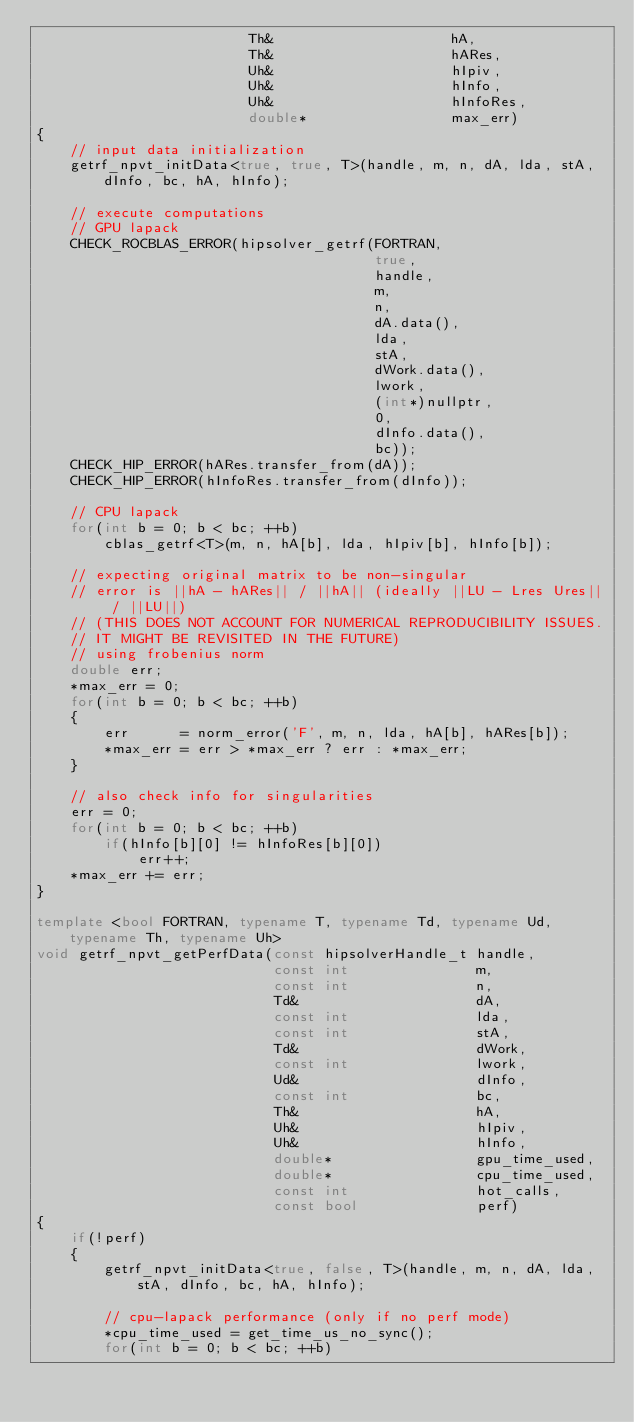<code> <loc_0><loc_0><loc_500><loc_500><_C++_>                         Th&                     hA,
                         Th&                     hARes,
                         Uh&                     hIpiv,
                         Uh&                     hInfo,
                         Uh&                     hInfoRes,
                         double*                 max_err)
{
    // input data initialization
    getrf_npvt_initData<true, true, T>(handle, m, n, dA, lda, stA, dInfo, bc, hA, hInfo);

    // execute computations
    // GPU lapack
    CHECK_ROCBLAS_ERROR(hipsolver_getrf(FORTRAN,
                                        true,
                                        handle,
                                        m,
                                        n,
                                        dA.data(),
                                        lda,
                                        stA,
                                        dWork.data(),
                                        lwork,
                                        (int*)nullptr,
                                        0,
                                        dInfo.data(),
                                        bc));
    CHECK_HIP_ERROR(hARes.transfer_from(dA));
    CHECK_HIP_ERROR(hInfoRes.transfer_from(dInfo));

    // CPU lapack
    for(int b = 0; b < bc; ++b)
        cblas_getrf<T>(m, n, hA[b], lda, hIpiv[b], hInfo[b]);

    // expecting original matrix to be non-singular
    // error is ||hA - hARes|| / ||hA|| (ideally ||LU - Lres Ures|| / ||LU||)
    // (THIS DOES NOT ACCOUNT FOR NUMERICAL REPRODUCIBILITY ISSUES.
    // IT MIGHT BE REVISITED IN THE FUTURE)
    // using frobenius norm
    double err;
    *max_err = 0;
    for(int b = 0; b < bc; ++b)
    {
        err      = norm_error('F', m, n, lda, hA[b], hARes[b]);
        *max_err = err > *max_err ? err : *max_err;
    }

    // also check info for singularities
    err = 0;
    for(int b = 0; b < bc; ++b)
        if(hInfo[b][0] != hInfoRes[b][0])
            err++;
    *max_err += err;
}

template <bool FORTRAN, typename T, typename Td, typename Ud, typename Th, typename Uh>
void getrf_npvt_getPerfData(const hipsolverHandle_t handle,
                            const int               m,
                            const int               n,
                            Td&                     dA,
                            const int               lda,
                            const int               stA,
                            Td&                     dWork,
                            const int               lwork,
                            Ud&                     dInfo,
                            const int               bc,
                            Th&                     hA,
                            Uh&                     hIpiv,
                            Uh&                     hInfo,
                            double*                 gpu_time_used,
                            double*                 cpu_time_used,
                            const int               hot_calls,
                            const bool              perf)
{
    if(!perf)
    {
        getrf_npvt_initData<true, false, T>(handle, m, n, dA, lda, stA, dInfo, bc, hA, hInfo);

        // cpu-lapack performance (only if no perf mode)
        *cpu_time_used = get_time_us_no_sync();
        for(int b = 0; b < bc; ++b)</code> 